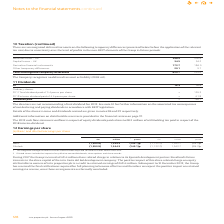According to Intu Properties's financial document, What is the amount of share related charge incurred by the Group in 2019? According to the financial document, £49.4 million. The relevant text states: "During 2017 the Group incurred a £49.4 million share related charge in relation to its Spanish development partner Eurofund’s future interests in t During 2017 the Group incurred a £49.4 million share..." Also, What do the diluted shares include? The document contains multiple relevant values: impact of any dilutive convertible bonds, share options, share awards. From the document: "ude the impact of any dilutive convertible bonds, share options and share awards. 2 Diluted shares include the impact of any dilutive convertible bond..." Also, What was the retained earnings in 2017? According to the financial document, £49.4 million. The relevant text states: "During 2017 the Group incurred a £49.4 million share related charge in relation to its Spanish development partner Eurofund’s future interests in t During 2017 the Group incurred a £49.4 million share..." Additionally, In which year is there a greater loss (million)? According to the financial document, 2019. The relevant text states: "128 intu properties plc Annual report 2019..." Additionally, In which year is there a greater loss per share (pence)? According to the financial document, 2019. The relevant text states: "128 intu properties plc Annual report 2019..." Additionally, In which year is there a greater number of shares? According to the financial document, 2019. The relevant text states: "128 intu properties plc Annual report 2019..." 